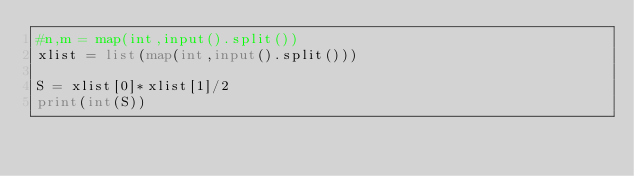Convert code to text. <code><loc_0><loc_0><loc_500><loc_500><_Python_>#n,m = map(int,input().split())
xlist = list(map(int,input().split()))

S = xlist[0]*xlist[1]/2
print(int(S))
</code> 